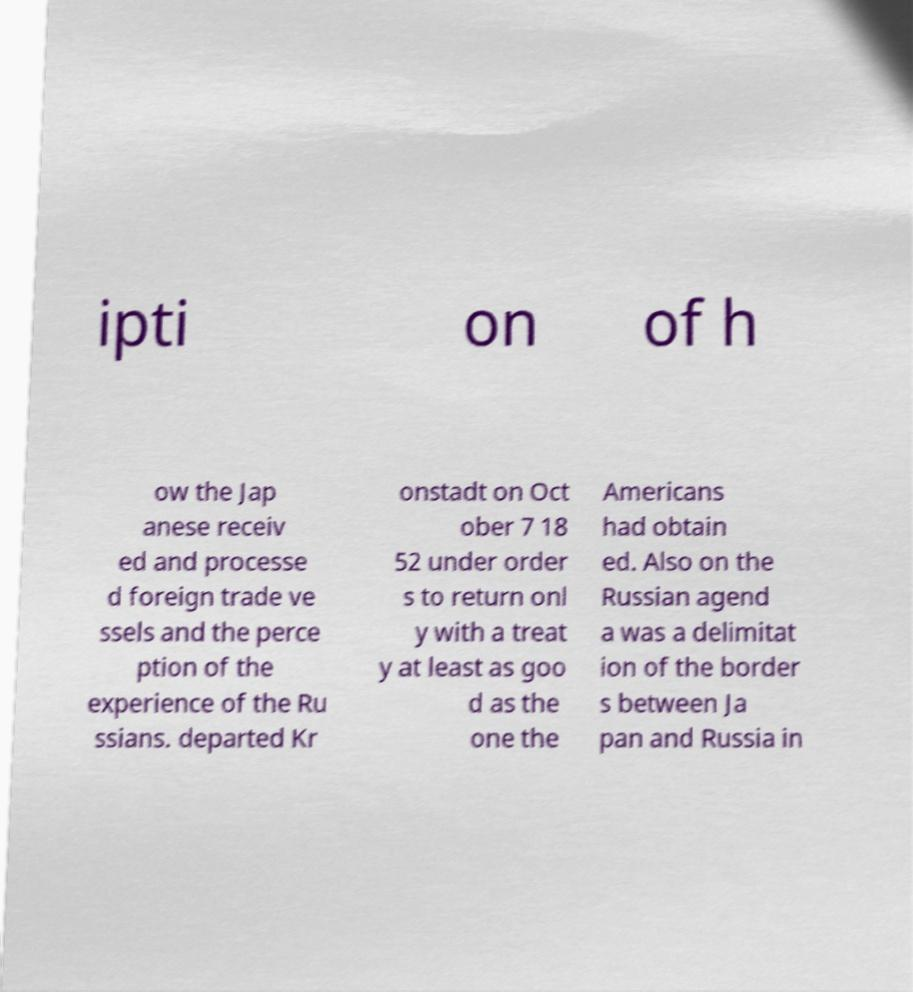I need the written content from this picture converted into text. Can you do that? ipti on of h ow the Jap anese receiv ed and processe d foreign trade ve ssels and the perce ption of the experience of the Ru ssians. departed Kr onstadt on Oct ober 7 18 52 under order s to return onl y with a treat y at least as goo d as the one the Americans had obtain ed. Also on the Russian agend a was a delimitat ion of the border s between Ja pan and Russia in 